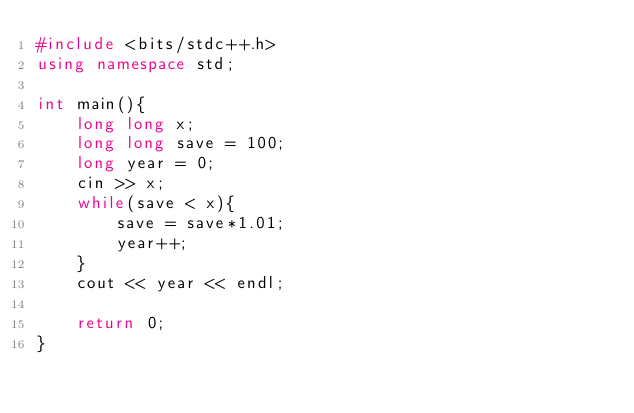<code> <loc_0><loc_0><loc_500><loc_500><_C++_>#include <bits/stdc++.h>
using namespace std;

int main(){
    long long x;
    long long save = 100;
    long year = 0;
    cin >> x;
    while(save < x){
        save = save*1.01;
        year++;
    }
    cout << year << endl;

    return 0;
}</code> 